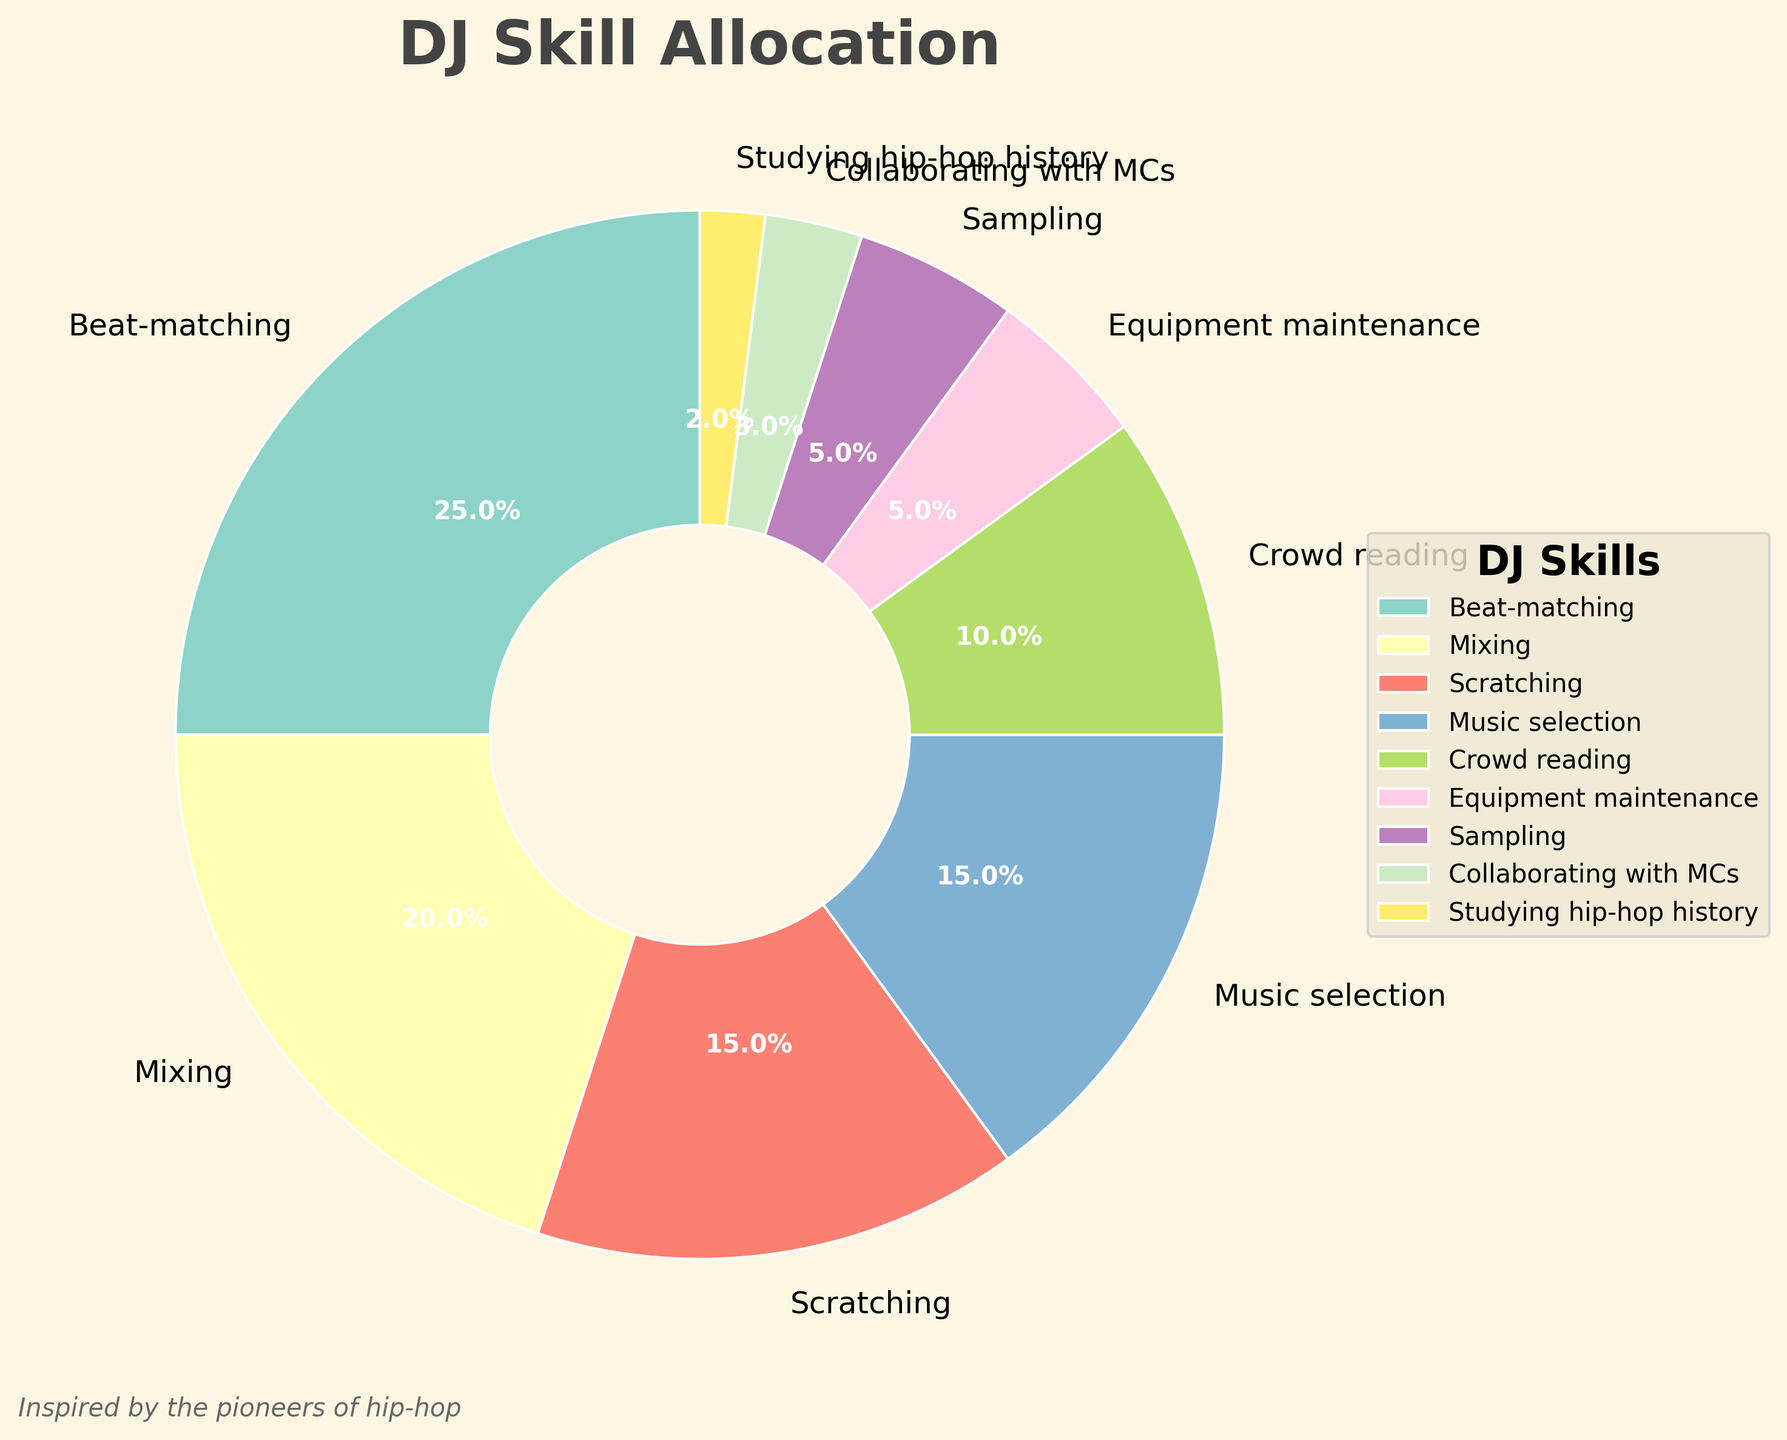What's the combined percentage of time spent on Beat-matching and Mixing? Sum the percentages of Beat-matching (25%) and Mixing (20%): 25 + 20 = 45
Answer: 45 Which skill has the largest allocation of time? The figure shows that Beat-matching has the highest percentage at 25%.
Answer: Beat-matching How much more time is spent on Scratching compared to Studying hip-hop history? Calculate the difference between Scratching (15%) and Studying hip-hop history (2%): 15 - 2 = 13
Answer: 13 If the overall time is reduced by 10% for each skill, what would be the new percentage for Crowd reading? Reduce Crowd reading's percentage by 10%: 10% - (10% * 0.1) = 10% - 1% = 9%
Answer: 9 Which skill takes up the smallest portion of time? According to the pie chart, Studying hip-hop history occupies the smallest portion with 2%.
Answer: Studying hip-hop history Is more time allocated to Equipment maintenance or Collaborating with MCs? Comparing the percentages, Equipment maintenance (5%) has more time allocated than Collaborating with MCs (3%).
Answer: Equipment maintenance How much total time is spent on Sampling, Crowd reading, and Equipment maintenance? Sum the percentages for Sampling (5%), Crowd reading (10%), and Equipment maintenance (5%): 5 + 10 + 5 = 20
Answer: 20 If we combine time spent on Music selection and Sampling, does it exceed the time spent on Mixing? Sum Music selection (15%) and Sampling (5%): 15 + 5 = 20, then compare it to Mixing (20%): 20% is equal to 20%.
Answer: No How does the percentage of time spent on Crowd reading compare to the average time spent on all skills? Calculate the average percentage: (25% + 20% + 15% + 15% + 10% + 5% + 5% + 3% + 2%) / 9 ≈ 11.11%. Crowd reading is 10%, which is less than the average.
Answer: Less Which wedges are located near the start angle (90 degrees) in the pie chart? The first few wedges starting from the 90-degree angle are Beat-matching and Mixing, based on their largest allocations and positioning in the pie chart.
Answer: Beat-matching and Mixing 